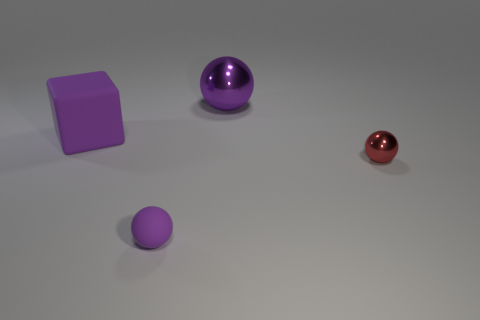Add 4 green matte objects. How many objects exist? 8 Subtract all cubes. How many objects are left? 3 Add 4 big things. How many big things are left? 6 Add 1 gray metallic cubes. How many gray metallic cubes exist? 1 Subtract 0 purple cylinders. How many objects are left? 4 Subtract all small shiny spheres. Subtract all shiny objects. How many objects are left? 1 